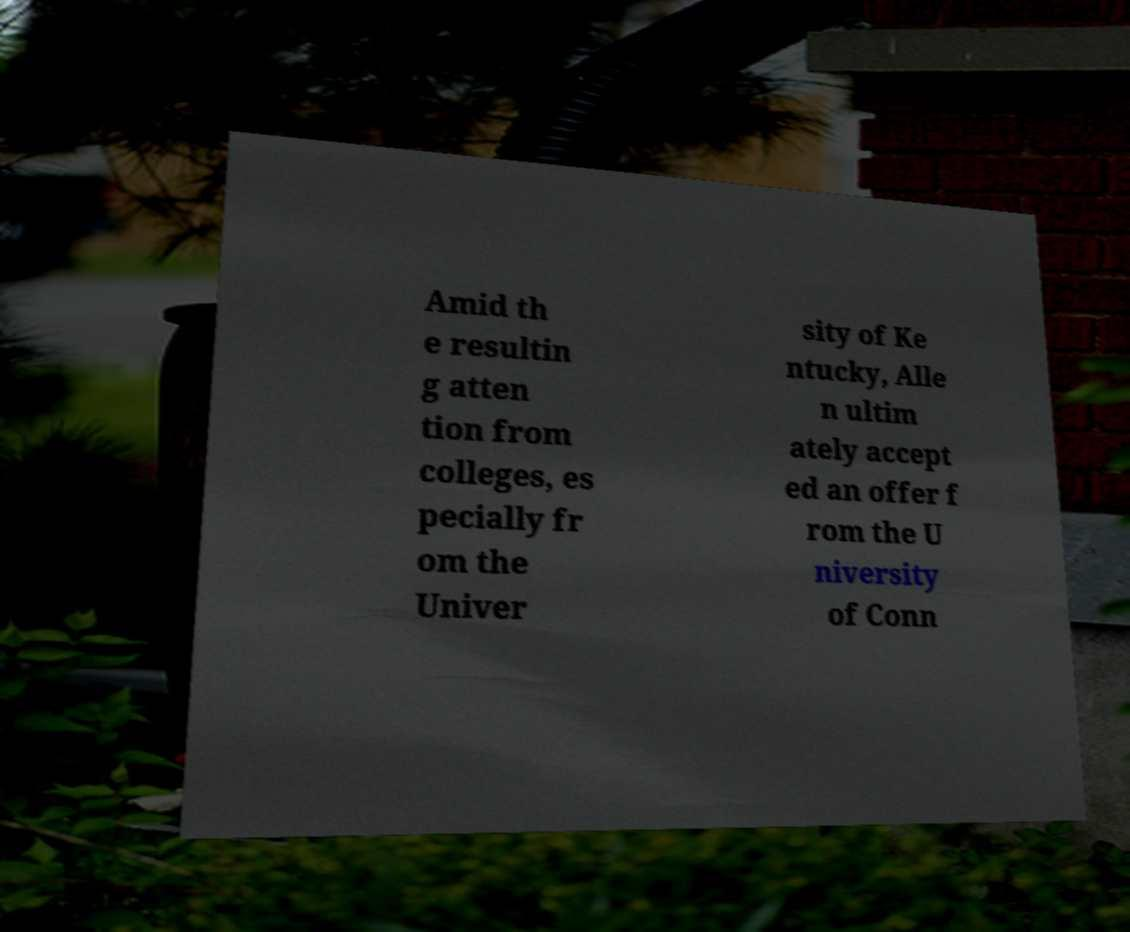Can you accurately transcribe the text from the provided image for me? Amid th e resultin g atten tion from colleges, es pecially fr om the Univer sity of Ke ntucky, Alle n ultim ately accept ed an offer f rom the U niversity of Conn 